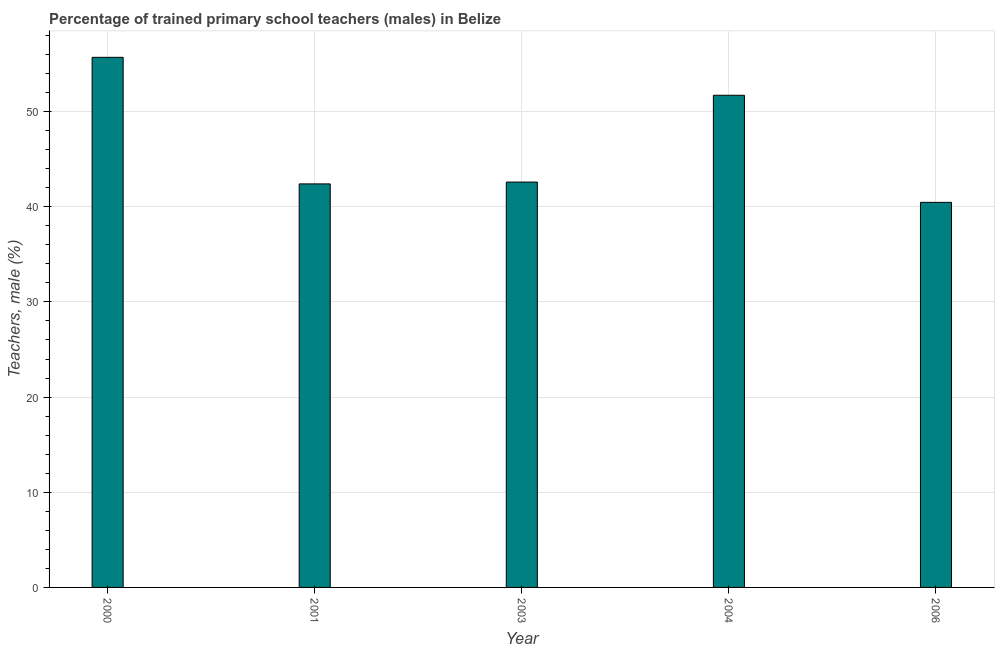Does the graph contain grids?
Provide a succinct answer. Yes. What is the title of the graph?
Provide a short and direct response. Percentage of trained primary school teachers (males) in Belize. What is the label or title of the X-axis?
Provide a short and direct response. Year. What is the label or title of the Y-axis?
Ensure brevity in your answer.  Teachers, male (%). What is the percentage of trained male teachers in 2006?
Keep it short and to the point. 40.46. Across all years, what is the maximum percentage of trained male teachers?
Your answer should be very brief. 55.7. Across all years, what is the minimum percentage of trained male teachers?
Offer a very short reply. 40.46. In which year was the percentage of trained male teachers maximum?
Provide a succinct answer. 2000. In which year was the percentage of trained male teachers minimum?
Provide a short and direct response. 2006. What is the sum of the percentage of trained male teachers?
Provide a short and direct response. 232.87. What is the difference between the percentage of trained male teachers in 2000 and 2004?
Offer a very short reply. 3.99. What is the average percentage of trained male teachers per year?
Offer a very short reply. 46.57. What is the median percentage of trained male teachers?
Provide a succinct answer. 42.59. In how many years, is the percentage of trained male teachers greater than 10 %?
Offer a very short reply. 5. What is the ratio of the percentage of trained male teachers in 2001 to that in 2004?
Your response must be concise. 0.82. Is the percentage of trained male teachers in 2001 less than that in 2006?
Keep it short and to the point. No. Is the difference between the percentage of trained male teachers in 2001 and 2006 greater than the difference between any two years?
Provide a succinct answer. No. What is the difference between the highest and the second highest percentage of trained male teachers?
Provide a short and direct response. 3.99. What is the difference between the highest and the lowest percentage of trained male teachers?
Keep it short and to the point. 15.24. How many bars are there?
Offer a very short reply. 5. Are all the bars in the graph horizontal?
Make the answer very short. No. How many years are there in the graph?
Keep it short and to the point. 5. Are the values on the major ticks of Y-axis written in scientific E-notation?
Give a very brief answer. No. What is the Teachers, male (%) in 2000?
Ensure brevity in your answer.  55.7. What is the Teachers, male (%) in 2001?
Provide a succinct answer. 42.4. What is the Teachers, male (%) in 2003?
Your answer should be very brief. 42.59. What is the Teachers, male (%) of 2004?
Your response must be concise. 51.71. What is the Teachers, male (%) of 2006?
Provide a short and direct response. 40.46. What is the difference between the Teachers, male (%) in 2000 and 2001?
Offer a terse response. 13.3. What is the difference between the Teachers, male (%) in 2000 and 2003?
Make the answer very short. 13.11. What is the difference between the Teachers, male (%) in 2000 and 2004?
Your answer should be very brief. 3.99. What is the difference between the Teachers, male (%) in 2000 and 2006?
Give a very brief answer. 15.24. What is the difference between the Teachers, male (%) in 2001 and 2003?
Make the answer very short. -0.19. What is the difference between the Teachers, male (%) in 2001 and 2004?
Your response must be concise. -9.31. What is the difference between the Teachers, male (%) in 2001 and 2006?
Offer a terse response. 1.94. What is the difference between the Teachers, male (%) in 2003 and 2004?
Give a very brief answer. -9.12. What is the difference between the Teachers, male (%) in 2003 and 2006?
Provide a succinct answer. 2.13. What is the difference between the Teachers, male (%) in 2004 and 2006?
Give a very brief answer. 11.25. What is the ratio of the Teachers, male (%) in 2000 to that in 2001?
Ensure brevity in your answer.  1.31. What is the ratio of the Teachers, male (%) in 2000 to that in 2003?
Give a very brief answer. 1.31. What is the ratio of the Teachers, male (%) in 2000 to that in 2004?
Your answer should be very brief. 1.08. What is the ratio of the Teachers, male (%) in 2000 to that in 2006?
Your answer should be very brief. 1.38. What is the ratio of the Teachers, male (%) in 2001 to that in 2004?
Offer a very short reply. 0.82. What is the ratio of the Teachers, male (%) in 2001 to that in 2006?
Offer a very short reply. 1.05. What is the ratio of the Teachers, male (%) in 2003 to that in 2004?
Provide a short and direct response. 0.82. What is the ratio of the Teachers, male (%) in 2003 to that in 2006?
Offer a very short reply. 1.05. What is the ratio of the Teachers, male (%) in 2004 to that in 2006?
Provide a short and direct response. 1.28. 